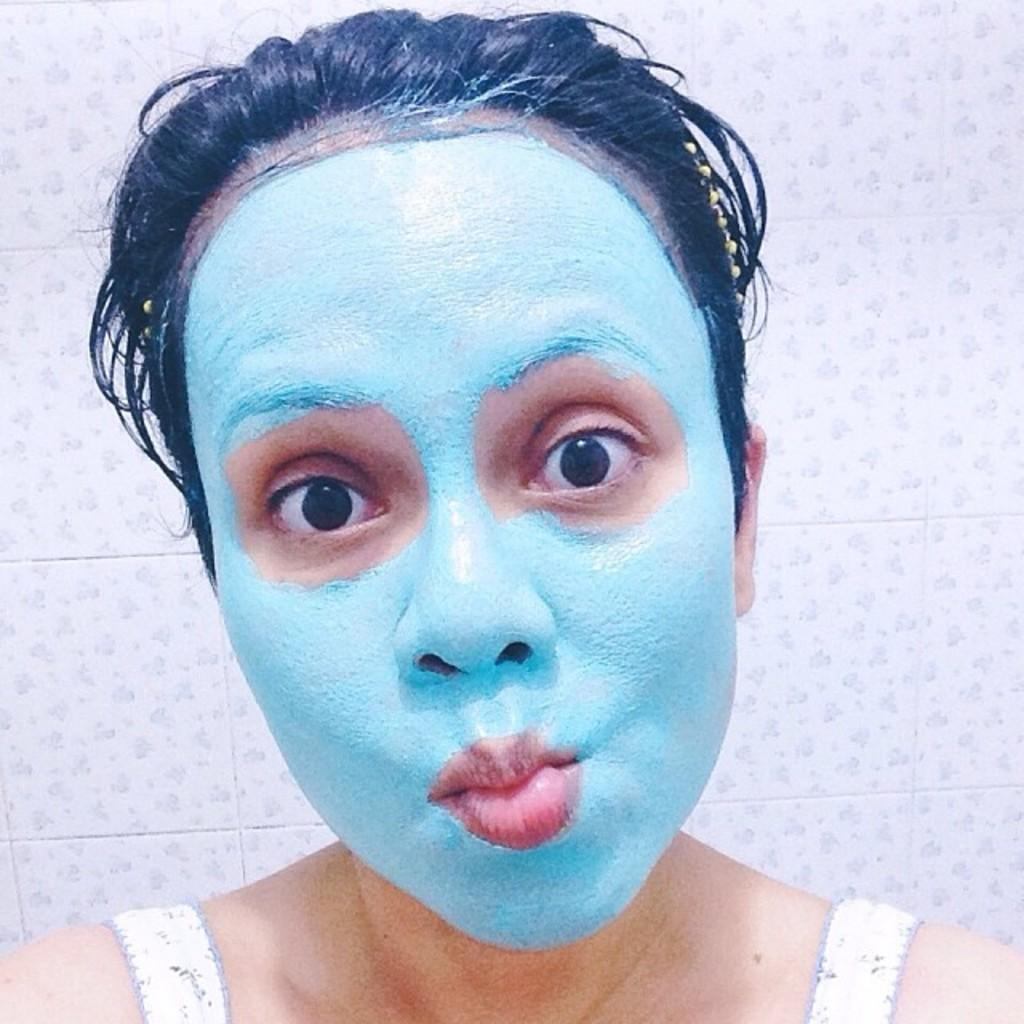Who is the main subject in the image? There is a woman in the image. What is the woman doing in the image? The woman has a face pack on. What direction is the woman looking in the image? The woman is looking forward. What day of the week is indicated on the calendar in the image? There is no calendar present in the image. What idea does the boy in the image have for his science project? There is no boy present in the image. 